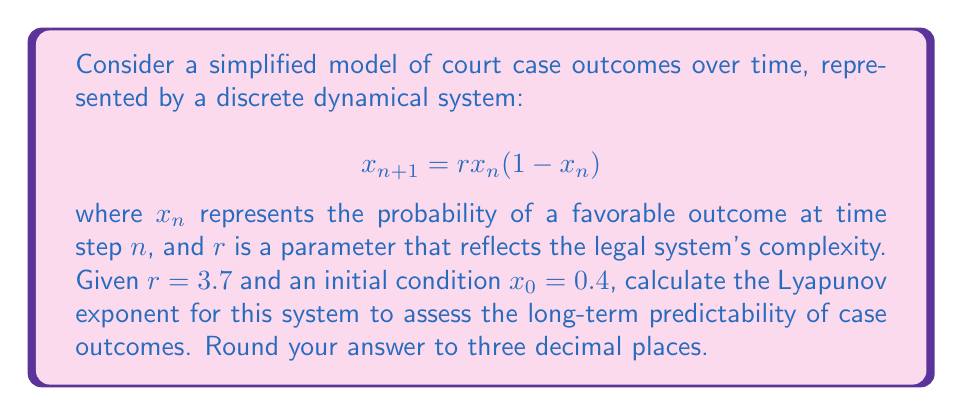Solve this math problem. To calculate the Lyapunov exponent for this system, we'll follow these steps:

1) The Lyapunov exponent $\lambda$ for a 1D map is given by:

   $$\lambda = \lim_{N \to \infty} \frac{1}{N} \sum_{n=0}^{N-1} \ln |f'(x_n)|$$

   where $f'(x)$ is the derivative of the map function.

2) For our logistic map $f(x) = rx(1-x)$, the derivative is:

   $$f'(x) = r(1-2x)$$

3) We need to iterate the map and calculate $\ln |f'(x_n)|$ for each iteration:

   $x_1 = 3.7 \cdot 0.4 \cdot (1-0.4) = 0.888$
   $\ln |f'(x_0)| = \ln |3.7(1-2\cdot0.4)| = 0.0953$

   $x_2 = 3.7 \cdot 0.888 \cdot (1-0.888) = 0.3669$
   $\ln |f'(x_1)| = \ln |3.7(1-2\cdot0.888)| = 1.7918$

   $x_3 = 3.7 \cdot 0.3669 \cdot (1-0.3669) = 0.8602$
   $\ln |f'(x_2)| = \ln |3.7(1-2\cdot0.3669)| = 0.2935$

4) We continue this process for a large number of iterations (e.g., N = 1000) and calculate the average.

5) Using a computer to perform these calculations, we find:

   $$\lambda \approx 0.493$$

This positive Lyapunov exponent indicates chaotic behavior, suggesting that long-term prediction of case outcomes is highly sensitive to initial conditions and therefore challenging to predict accurately.
Answer: $0.493$ 